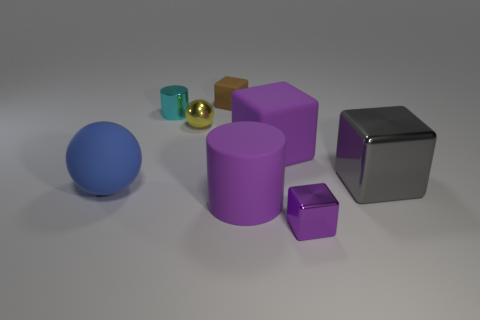There is a ball in front of the tiny yellow ball; is there a small cyan thing that is in front of it?
Keep it short and to the point. No. What number of large cyan objects are there?
Offer a terse response. 0. What is the color of the object that is to the right of the rubber cylinder and in front of the blue rubber sphere?
Provide a short and direct response. Purple. There is another metal thing that is the same shape as the small purple thing; what size is it?
Your answer should be very brief. Large. How many purple metallic things have the same size as the purple shiny block?
Provide a succinct answer. 0. What is the big purple block made of?
Provide a short and direct response. Rubber. There is a tiny brown block; are there any big blue matte things to the right of it?
Your response must be concise. No. The yellow object that is the same material as the gray object is what size?
Offer a terse response. Small. How many metallic blocks have the same color as the large matte cylinder?
Make the answer very short. 1. Is the number of cyan objects that are right of the cyan metallic thing less than the number of big matte things in front of the purple metal cube?
Provide a short and direct response. No. 